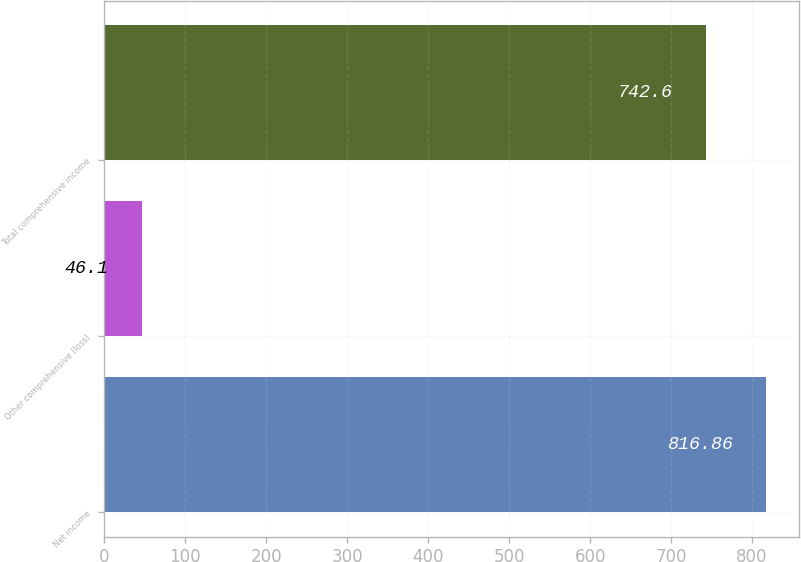<chart> <loc_0><loc_0><loc_500><loc_500><bar_chart><fcel>Net income<fcel>Other comprehensive (loss)<fcel>Total comprehensive income<nl><fcel>816.86<fcel>46.1<fcel>742.6<nl></chart> 